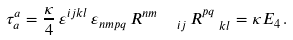<formula> <loc_0><loc_0><loc_500><loc_500>\tau _ { a } ^ { a } = \frac { \kappa } { 4 } \, \varepsilon ^ { i j k l } \, \varepsilon _ { n m p q } \, R _ { \quad i j } ^ { n m } \, R _ { \ \ k l } ^ { p q } = \kappa E _ { 4 } \, .</formula> 